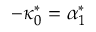<formula> <loc_0><loc_0><loc_500><loc_500>- \kappa _ { 0 } ^ { * } = \alpha _ { 1 } ^ { * }</formula> 